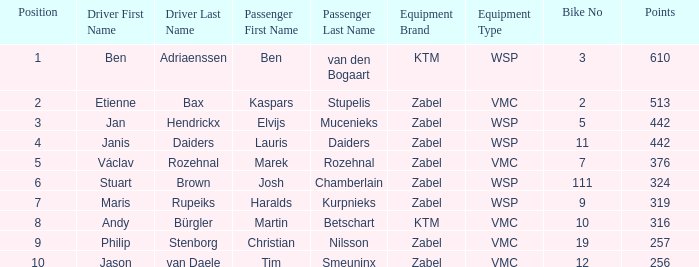What is the most elevated Position that has a Points of 257, and a Bike No littler than 19? None. 